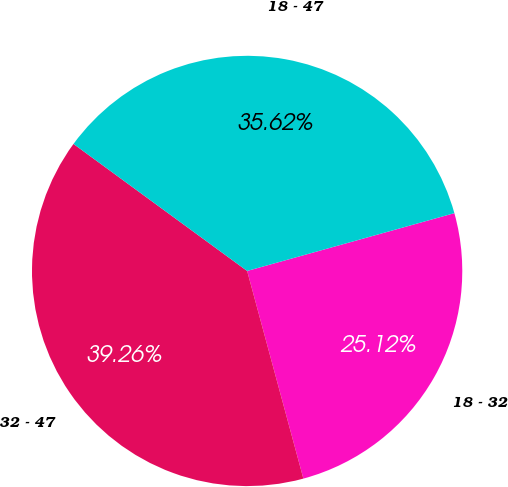Convert chart to OTSL. <chart><loc_0><loc_0><loc_500><loc_500><pie_chart><fcel>18 - 32<fcel>32 - 47<fcel>18 - 47<nl><fcel>25.12%<fcel>39.26%<fcel>35.62%<nl></chart> 